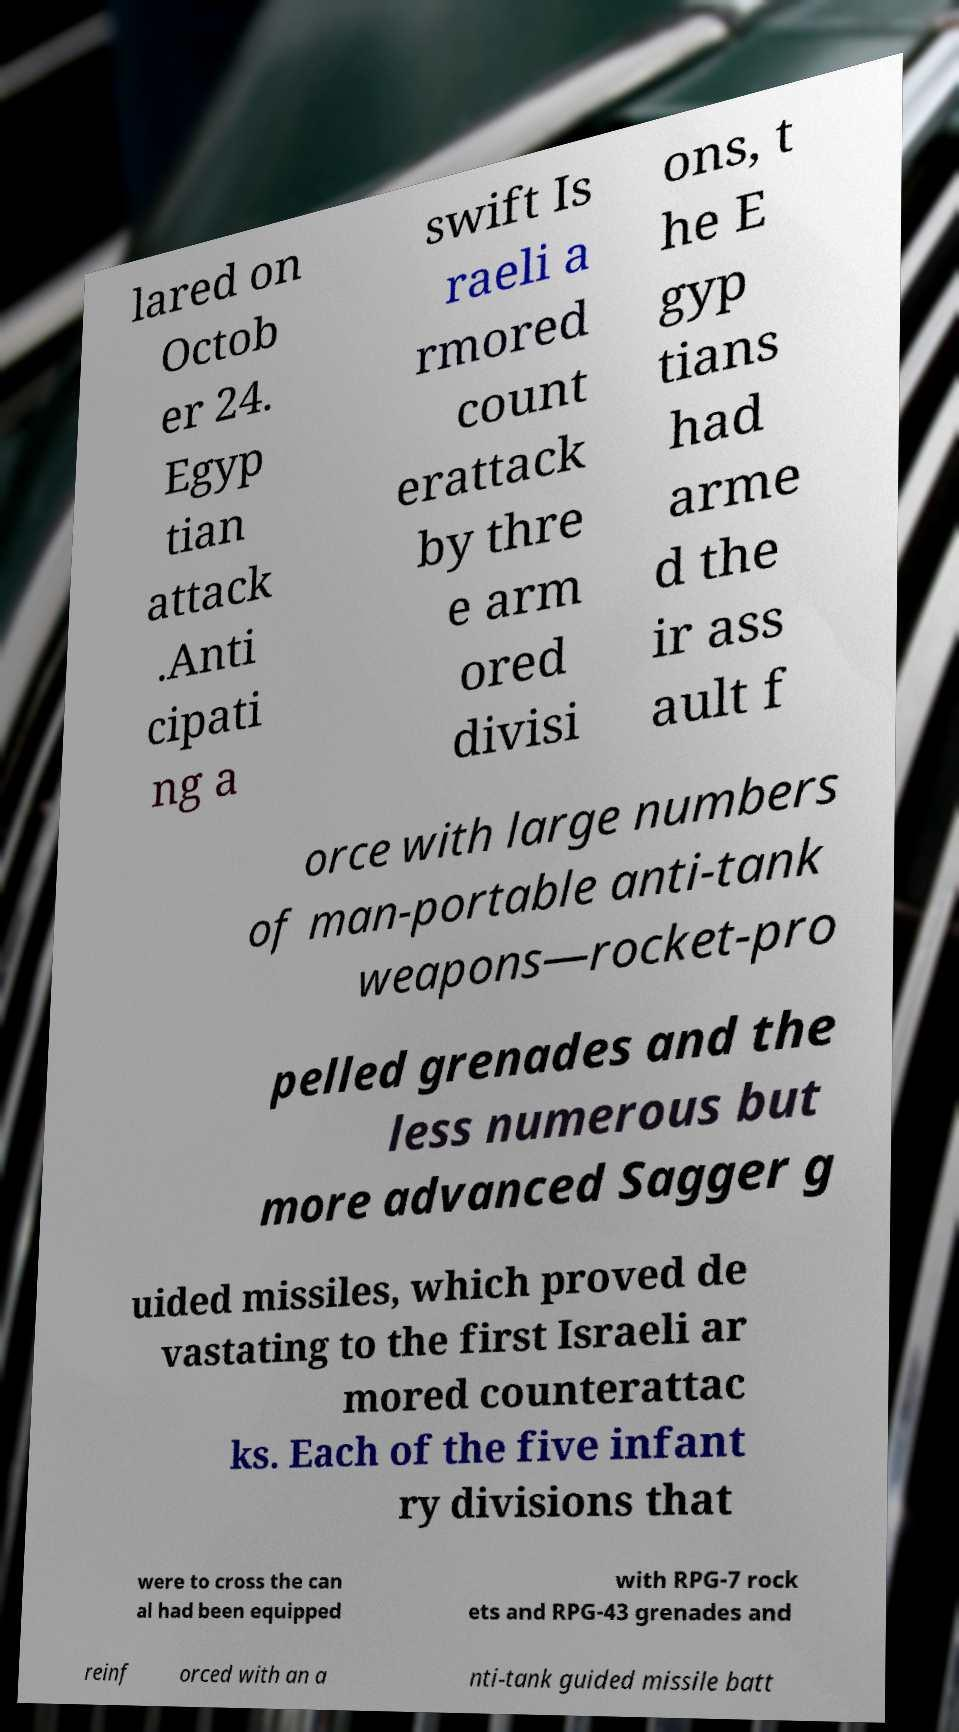What messages or text are displayed in this image? I need them in a readable, typed format. lared on Octob er 24. Egyp tian attack .Anti cipati ng a swift Is raeli a rmored count erattack by thre e arm ored divisi ons, t he E gyp tians had arme d the ir ass ault f orce with large numbers of man-portable anti-tank weapons—rocket-pro pelled grenades and the less numerous but more advanced Sagger g uided missiles, which proved de vastating to the first Israeli ar mored counterattac ks. Each of the five infant ry divisions that were to cross the can al had been equipped with RPG-7 rock ets and RPG-43 grenades and reinf orced with an a nti-tank guided missile batt 